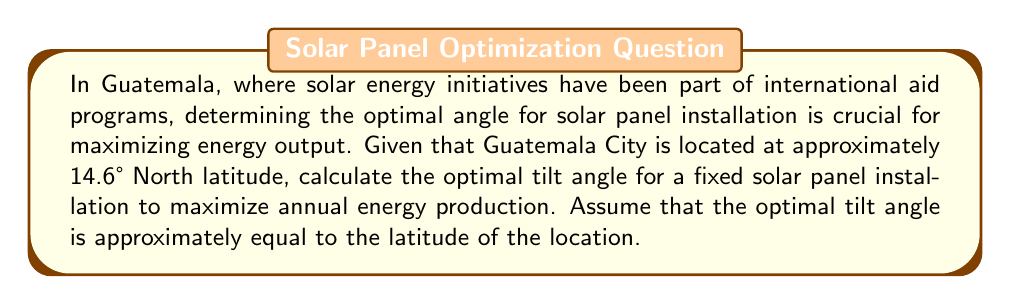Show me your answer to this math problem. To solve this problem, we need to understand the relationship between latitude and optimal solar panel tilt angle:

1. The general rule of thumb for fixed solar panel installations is that the optimal tilt angle is approximately equal to the latitude of the location. This maximizes the annual energy production by optimizing the angle of incidence of solar radiation throughout the year.

2. Guatemala City's latitude is given as 14.6° North.

3. Therefore, the optimal tilt angle can be calculated as follows:

   $$\text{Optimal Tilt Angle} \approx \text{Latitude}$$

   $$\text{Optimal Tilt Angle} \approx 14.6°$$

4. In practice, this angle might be adjusted slightly (usually by ±5°) based on local climate conditions, such as prevalent cloud cover or seasonal variations. However, for this calculation, we'll use the latitude directly.

5. The tilt angle is measured from the horizontal plane. This means that a panel installed at 14.6° would form an angle of 14.6° with the ground, with its top edge pointing towards the equator (which is south in this case, as Guatemala is in the Northern Hemisphere).

[asy]
import geometry;

size(200);
draw((0,0)--(100,0), arrow=Arrow(TeXHead));
draw((0,0)--(0,100), arrow=Arrow(TeXHead));
draw((0,0)--(100,25.8819), arrow=Arrow(TeXHead));
label("Ground", (50,-10));
label("Vertical", (-10,50));
label("Solar Panel", (70,20));
draw((90,0)..(100,25.8819), arc=ArcArrow(StickInterior));
label("14.6°", (95,10));
[/asy]
Answer: The optimal tilt angle for a fixed solar panel installation in Guatemala City is approximately $14.6°$ from the horizontal, facing south. 